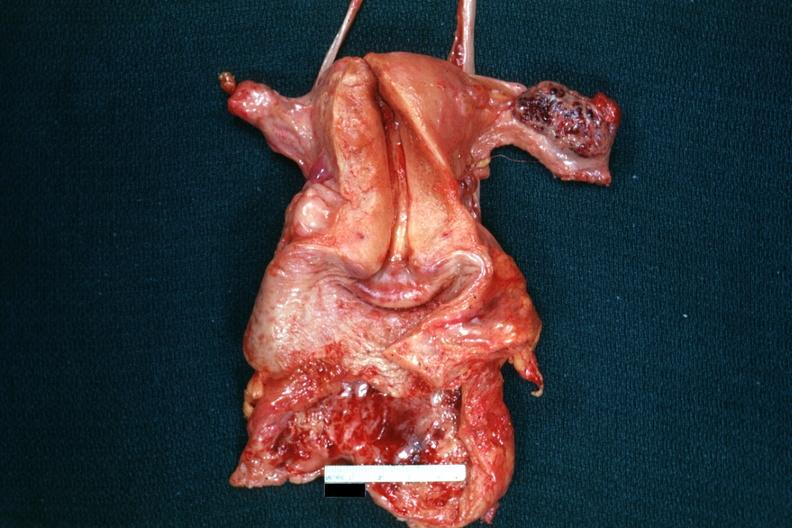does beckwith-wiedemann syndrome show opened uterus with adnexa and hemorrhagic mass in ovary?
Answer the question using a single word or phrase. No 